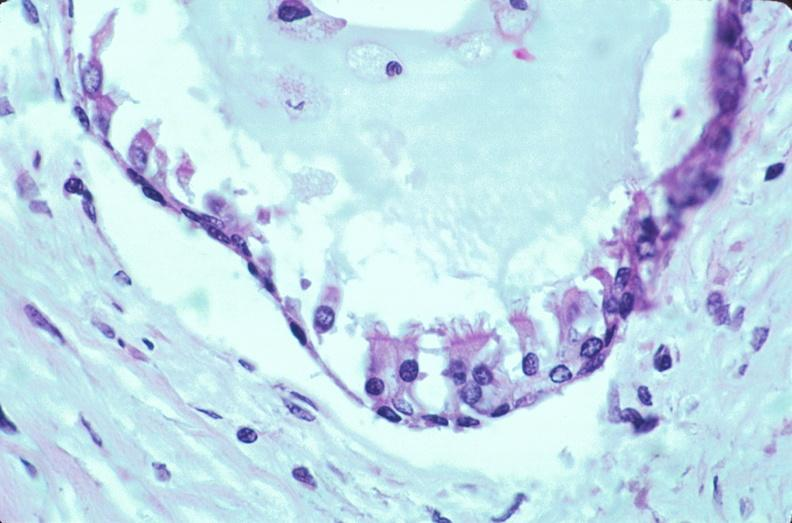does this image show pharyngeal pouch remnant, incidental finding in an adult?
Answer the question using a single word or phrase. Yes 